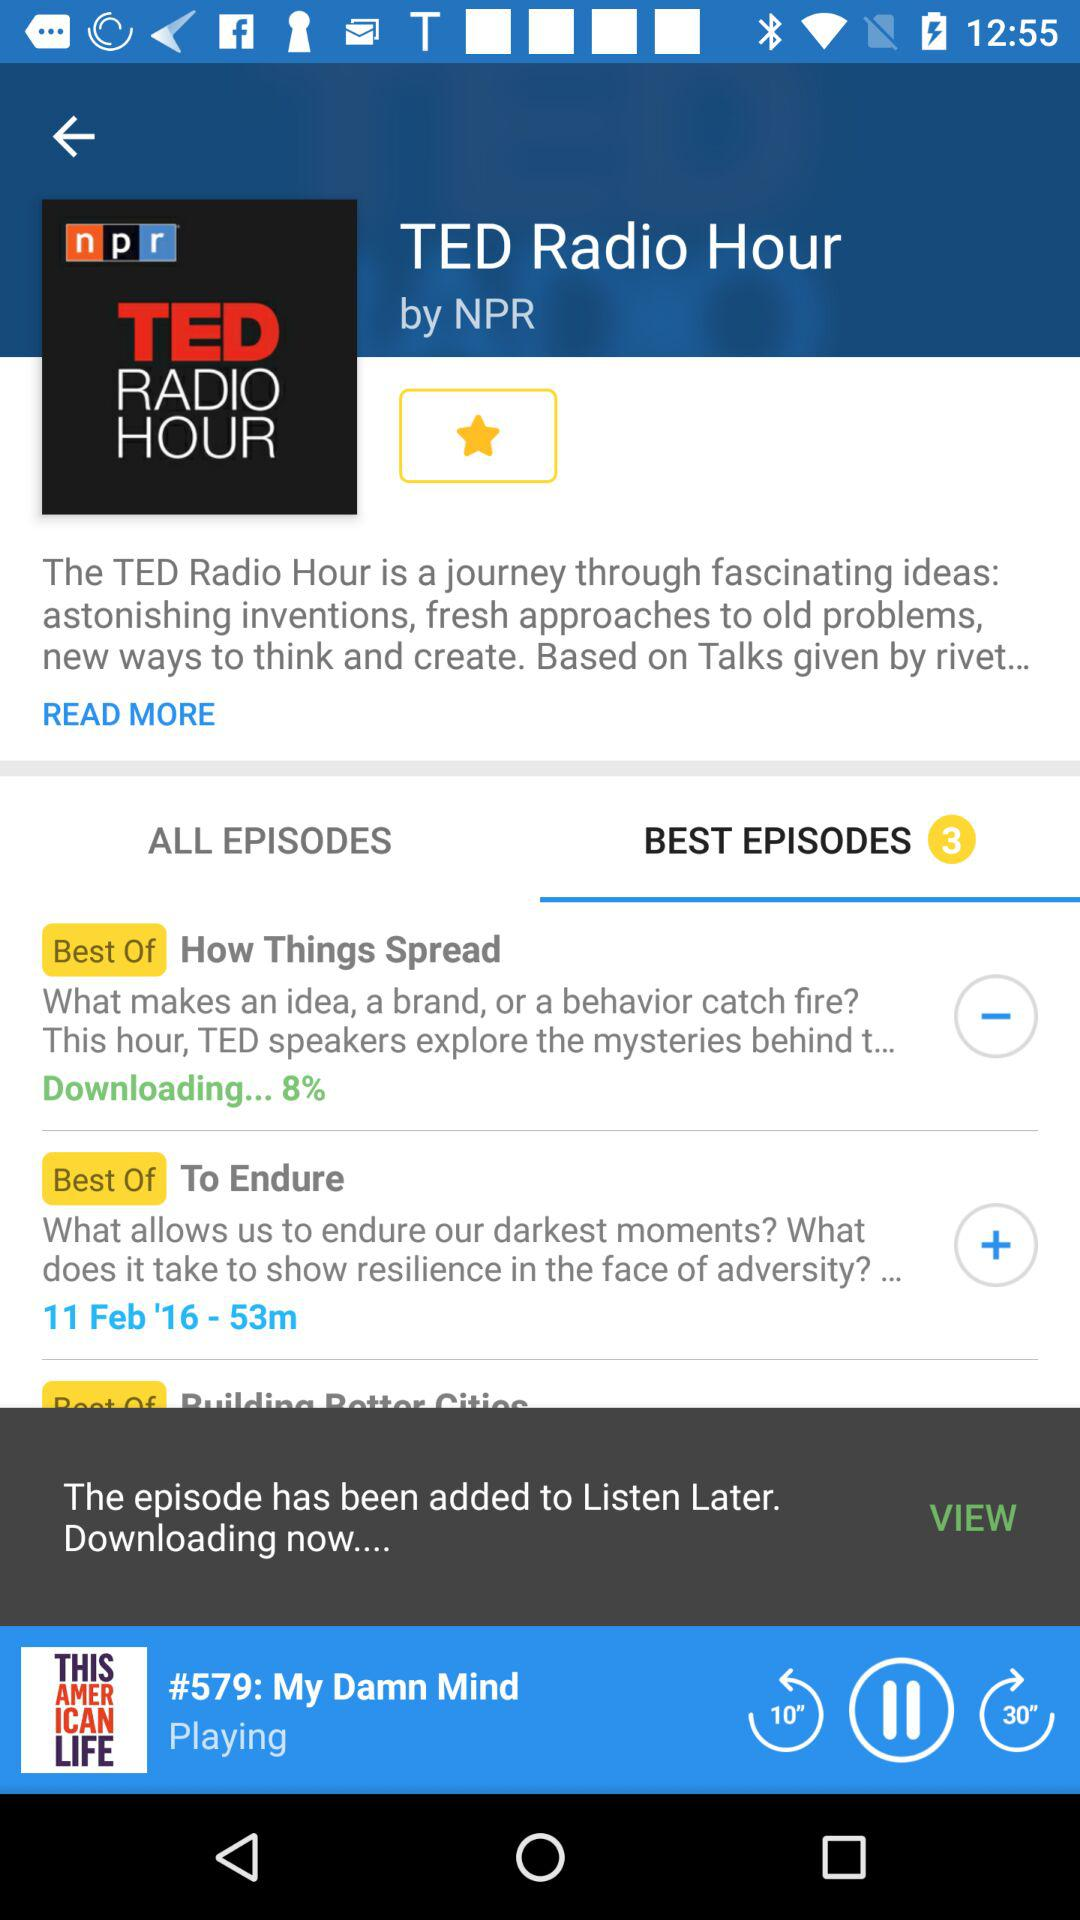What is the episode number for the "To endure"?
When the provided information is insufficient, respond with <no answer>. <no answer> 